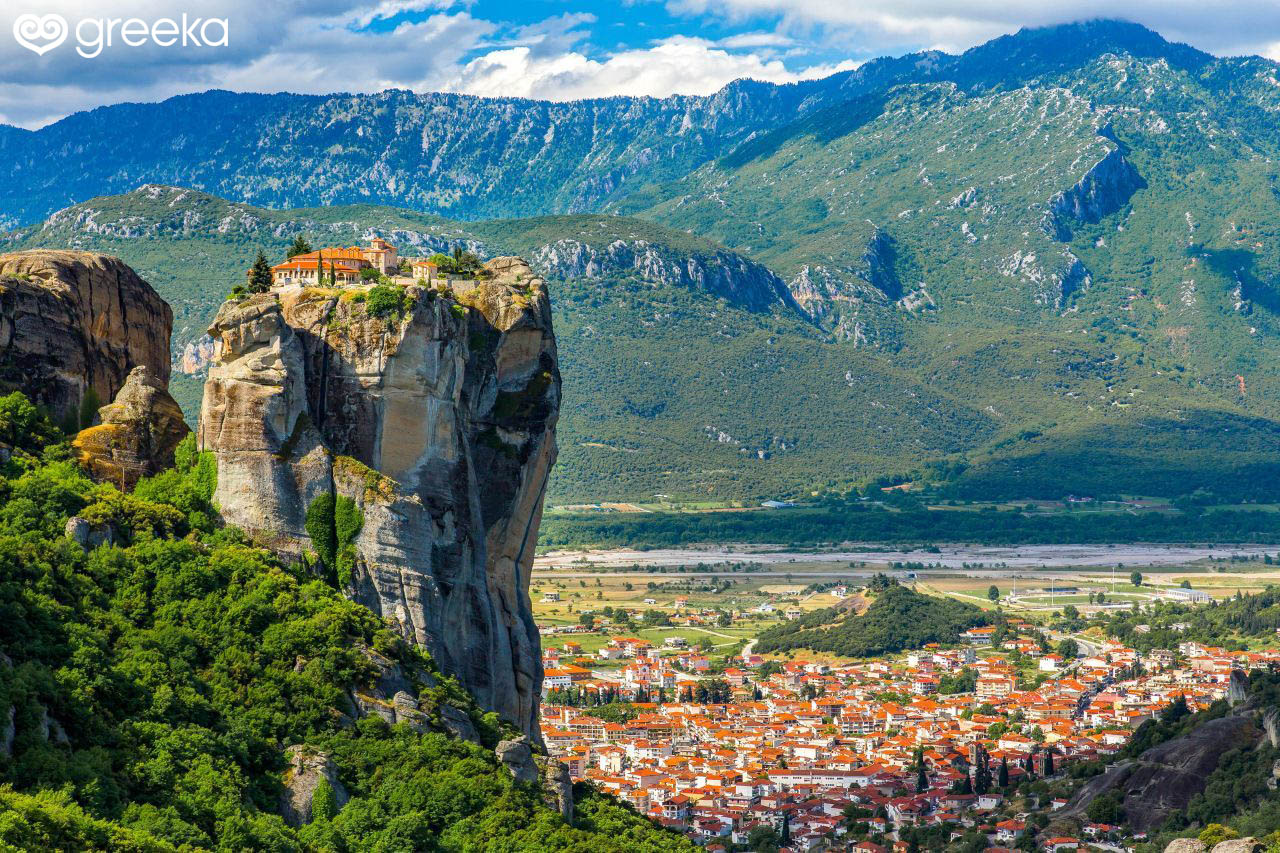How does the natural landscape complement the architectural elements in the image? The natural landscape of Meteora greatly complements the architectural elements seen in this image. The towering rock formations provide a majestic and nearly otherworldly setting for the monasteries, which seem to float above the valley below. The strategic and seemingly impossible placement of these structures showcases the ingenuity and determination of the monks who built them. The greenery in patches on the rocks softens the starkness of the stone and ties the structures into their natural surroundings. Meanwhile, the vibrant red-roofed buildings of the town below add a warm, lively touch that contrasts beautifully with the rugged cliffs and verdant mountains in the distance. If these rock formations could tell a story, what would they say about their past? If the rock formations of Meteora could tell a story, they'd recount tales of resilience and faith. They’d speak of ancient seas that carved them into towering pillars, and of the early ascetic monks who saw in them opportunities for retreat and divine contemplation. They'd narrate the efforts of those who hauled materials up impossible heights, driven by a desire to create sanctuaries closer to the heavens. They’d describe centuries of solitude, prayers echoing off stone, and of the changing world observed from their vantage points. They would recall the reverent footsteps of pilgrims and the modern visitors in awe of their timeless majesty.  Imagine the Monastery at the peak of the rock at sunrise, what would it look like? At sunrise, the Monastery perched atop the peak of Meteora would be bathed in a soft golden light, bringing the stone walls and terracotta roofs to life. The first rays of sun would cast long shadows, accentuating the texture of the rock and the architectural details of the monastery. A gentle morning mist might rise from the valleys below, giving the scene an ethereal, almost mystical quality. The sky would be streaked with shades of pink, orange, and purple, reflecting on the stone and seeming to wrap the monastery in a warm embrace. This serene and almost magical moment would highlight the tranquility and spiritual solitude of this lofty sanctuary. 